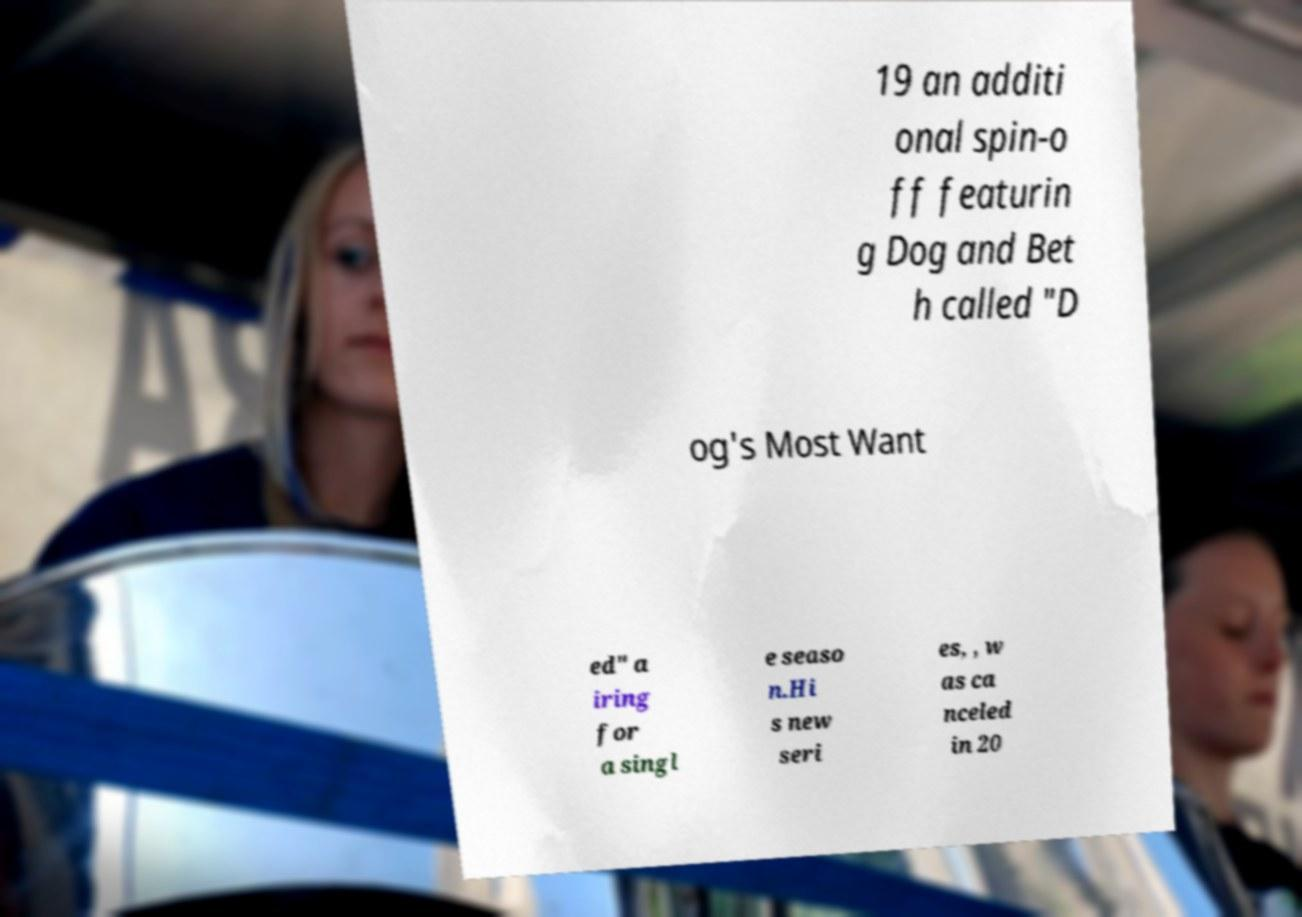I need the written content from this picture converted into text. Can you do that? 19 an additi onal spin-o ff featurin g Dog and Bet h called "D og's Most Want ed" a iring for a singl e seaso n.Hi s new seri es, , w as ca nceled in 20 